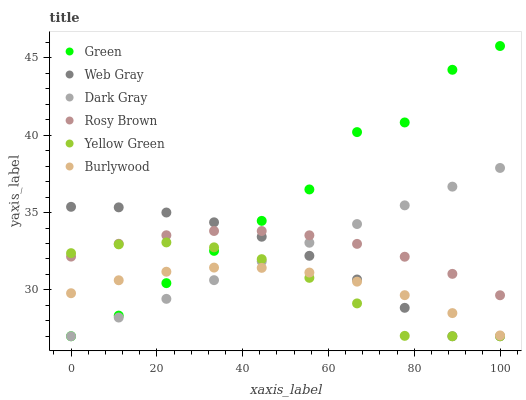Does Burlywood have the minimum area under the curve?
Answer yes or no. Yes. Does Green have the maximum area under the curve?
Answer yes or no. Yes. Does Yellow Green have the minimum area under the curve?
Answer yes or no. No. Does Yellow Green have the maximum area under the curve?
Answer yes or no. No. Is Dark Gray the smoothest?
Answer yes or no. Yes. Is Green the roughest?
Answer yes or no. Yes. Is Yellow Green the smoothest?
Answer yes or no. No. Is Yellow Green the roughest?
Answer yes or no. No. Does Web Gray have the lowest value?
Answer yes or no. Yes. Does Burlywood have the lowest value?
Answer yes or no. No. Does Green have the highest value?
Answer yes or no. Yes. Does Yellow Green have the highest value?
Answer yes or no. No. Is Burlywood less than Rosy Brown?
Answer yes or no. Yes. Is Rosy Brown greater than Burlywood?
Answer yes or no. Yes. Does Green intersect Yellow Green?
Answer yes or no. Yes. Is Green less than Yellow Green?
Answer yes or no. No. Is Green greater than Yellow Green?
Answer yes or no. No. Does Burlywood intersect Rosy Brown?
Answer yes or no. No. 